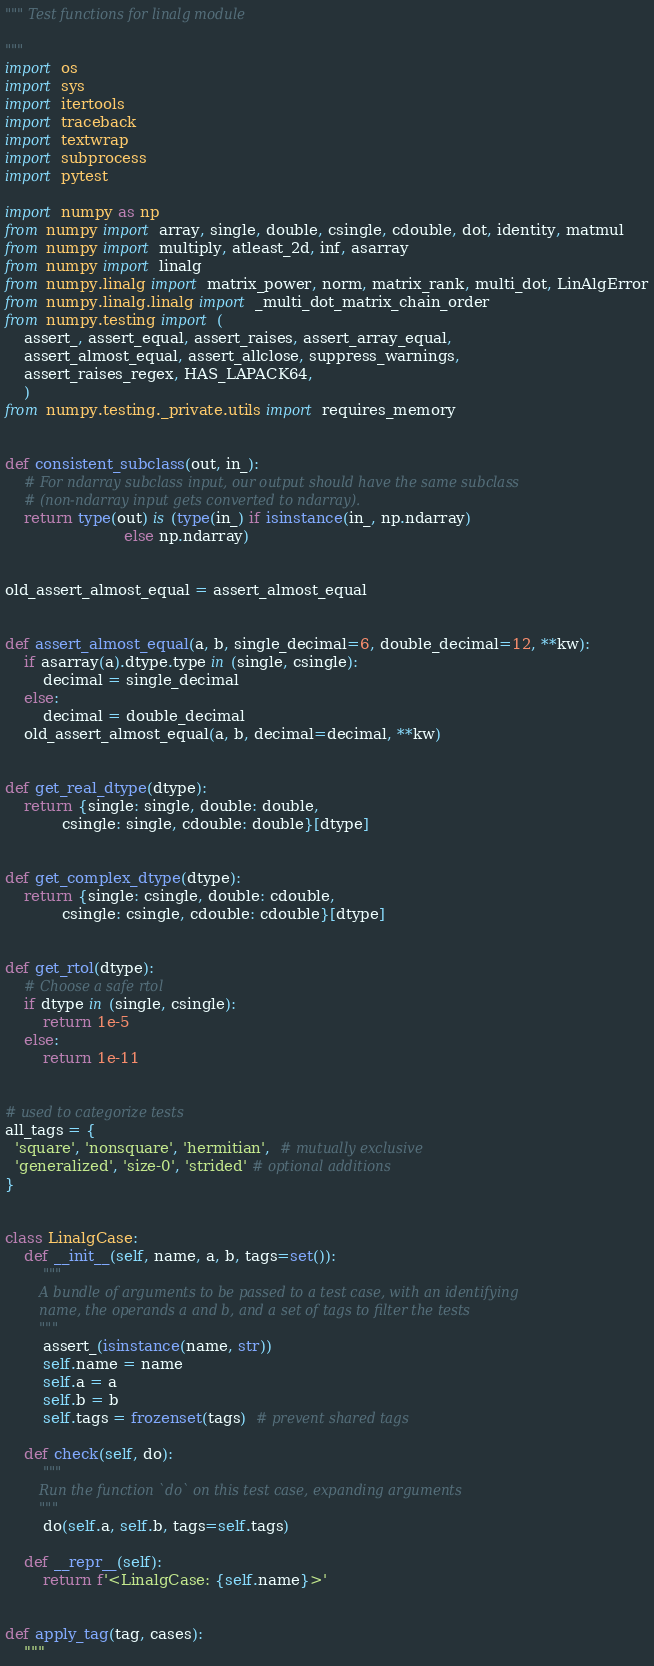<code> <loc_0><loc_0><loc_500><loc_500><_Python_>""" Test functions for linalg module

"""
import os
import sys
import itertools
import traceback
import textwrap
import subprocess
import pytest

import numpy as np
from numpy import array, single, double, csingle, cdouble, dot, identity, matmul
from numpy import multiply, atleast_2d, inf, asarray
from numpy import linalg
from numpy.linalg import matrix_power, norm, matrix_rank, multi_dot, LinAlgError
from numpy.linalg.linalg import _multi_dot_matrix_chain_order
from numpy.testing import (
    assert_, assert_equal, assert_raises, assert_array_equal,
    assert_almost_equal, assert_allclose, suppress_warnings,
    assert_raises_regex, HAS_LAPACK64,
    )
from numpy.testing._private.utils import requires_memory


def consistent_subclass(out, in_):
    # For ndarray subclass input, our output should have the same subclass
    # (non-ndarray input gets converted to ndarray).
    return type(out) is (type(in_) if isinstance(in_, np.ndarray)
                         else np.ndarray)


old_assert_almost_equal = assert_almost_equal


def assert_almost_equal(a, b, single_decimal=6, double_decimal=12, **kw):
    if asarray(a).dtype.type in (single, csingle):
        decimal = single_decimal
    else:
        decimal = double_decimal
    old_assert_almost_equal(a, b, decimal=decimal, **kw)


def get_real_dtype(dtype):
    return {single: single, double: double,
            csingle: single, cdouble: double}[dtype]


def get_complex_dtype(dtype):
    return {single: csingle, double: cdouble,
            csingle: csingle, cdouble: cdouble}[dtype]


def get_rtol(dtype):
    # Choose a safe rtol
    if dtype in (single, csingle):
        return 1e-5
    else:
        return 1e-11


# used to categorize tests
all_tags = {
  'square', 'nonsquare', 'hermitian',  # mutually exclusive
  'generalized', 'size-0', 'strided' # optional additions
}


class LinalgCase:
    def __init__(self, name, a, b, tags=set()):
        """
        A bundle of arguments to be passed to a test case, with an identifying
        name, the operands a and b, and a set of tags to filter the tests
        """
        assert_(isinstance(name, str))
        self.name = name
        self.a = a
        self.b = b
        self.tags = frozenset(tags)  # prevent shared tags

    def check(self, do):
        """
        Run the function `do` on this test case, expanding arguments
        """
        do(self.a, self.b, tags=self.tags)

    def __repr__(self):
        return f'<LinalgCase: {self.name}>'


def apply_tag(tag, cases):
    """</code> 